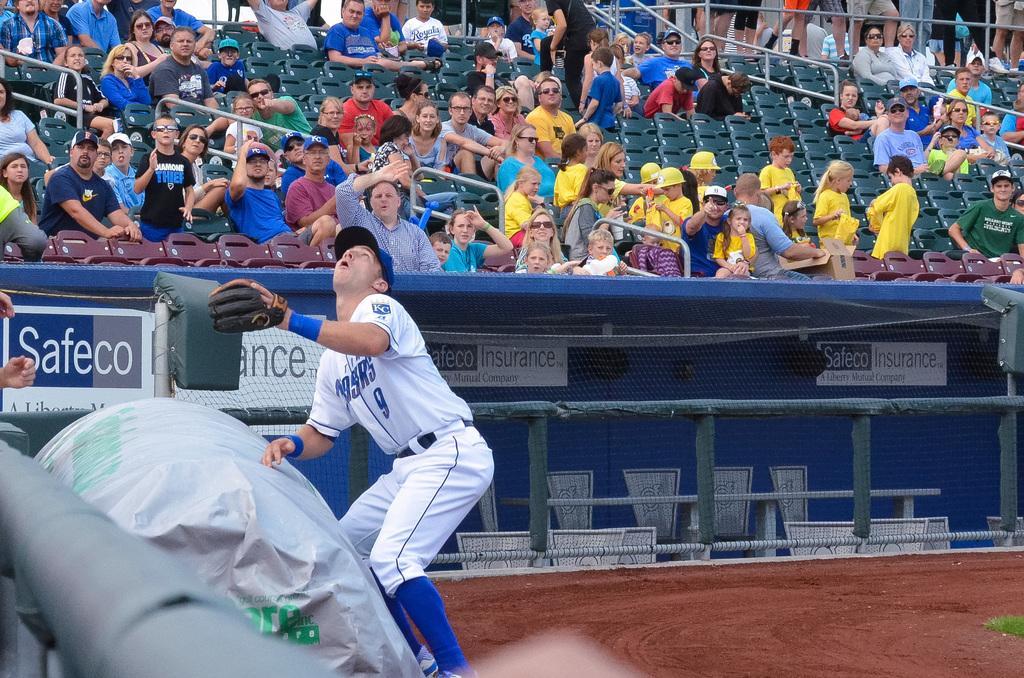Could you give a brief overview of what you see in this image? In this image I can see a group of people sitting on the green chairs. In front I can see a net fencing, few objects and one person is wearing white and blue color dress. 